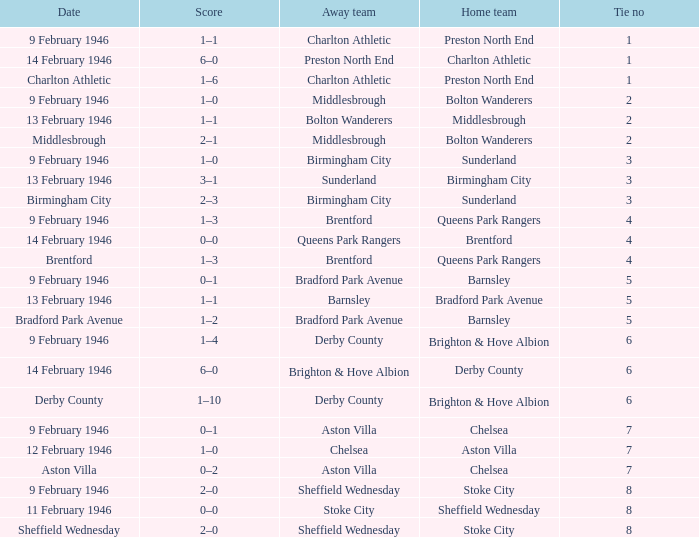What was the highest Tie no when the home team was the Bolton Wanderers, and the date was Middlesbrough? 2.0. 